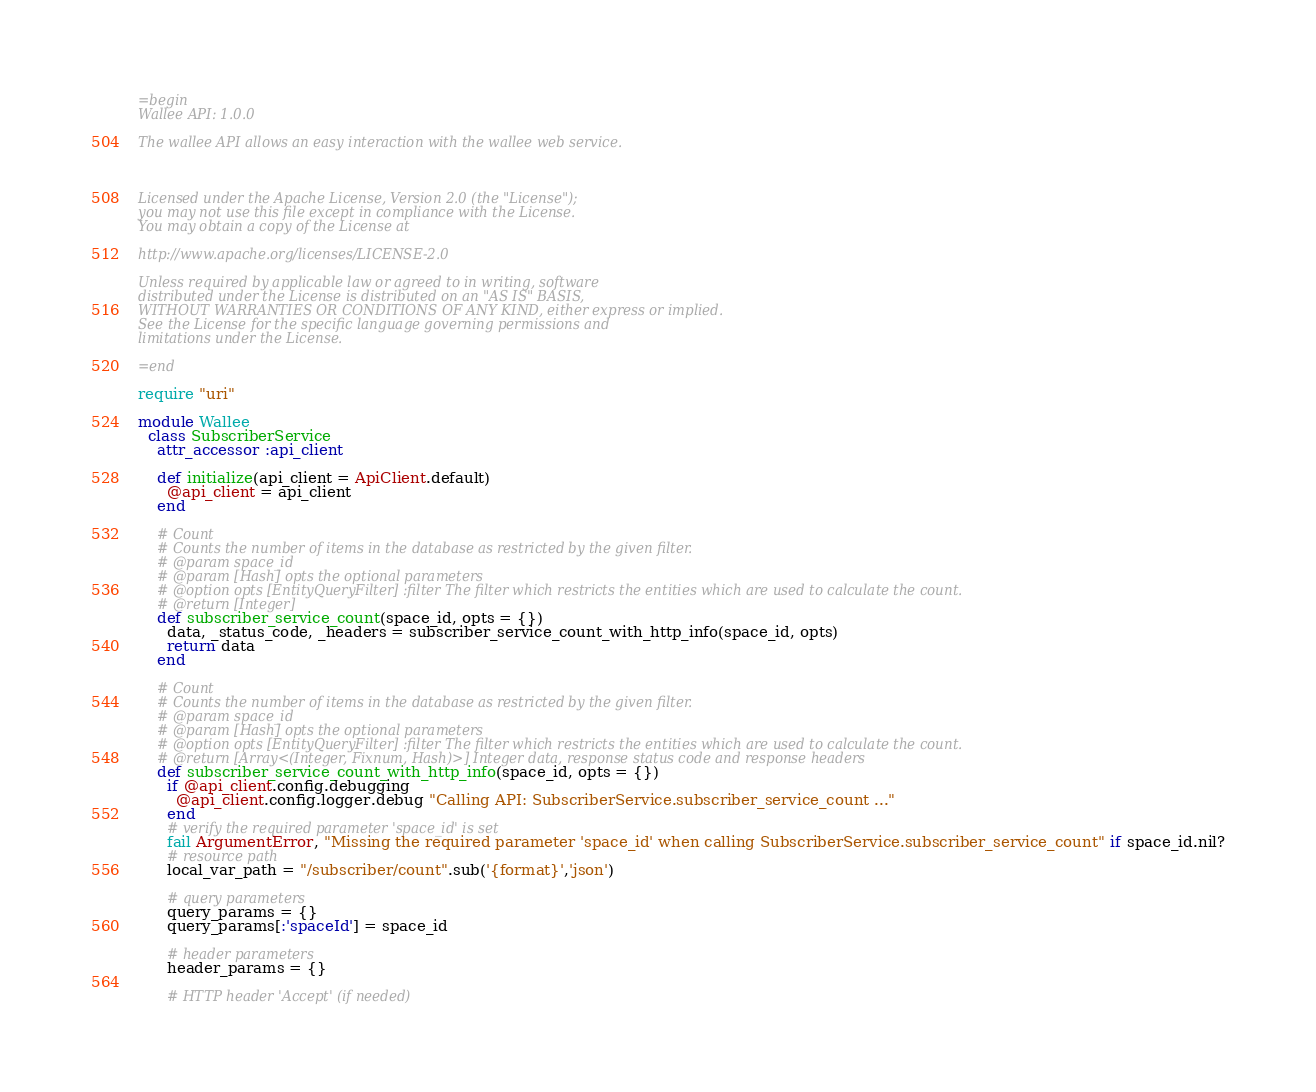<code> <loc_0><loc_0><loc_500><loc_500><_Ruby_>=begin
Wallee API: 1.0.0

The wallee API allows an easy interaction with the wallee web service.



Licensed under the Apache License, Version 2.0 (the "License");
you may not use this file except in compliance with the License.
You may obtain a copy of the License at

http://www.apache.org/licenses/LICENSE-2.0

Unless required by applicable law or agreed to in writing, software
distributed under the License is distributed on an "AS IS" BASIS,
WITHOUT WARRANTIES OR CONDITIONS OF ANY KIND, either express or implied.
See the License for the specific language governing permissions and
limitations under the License.

=end

require "uri"

module Wallee
  class SubscriberService
    attr_accessor :api_client

    def initialize(api_client = ApiClient.default)
      @api_client = api_client
    end

    # Count
    # Counts the number of items in the database as restricted by the given filter.
    # @param space_id 
    # @param [Hash] opts the optional parameters
    # @option opts [EntityQueryFilter] :filter The filter which restricts the entities which are used to calculate the count.
    # @return [Integer]
    def subscriber_service_count(space_id, opts = {})
      data, _status_code, _headers = subscriber_service_count_with_http_info(space_id, opts)
      return data
    end

    # Count
    # Counts the number of items in the database as restricted by the given filter.
    # @param space_id 
    # @param [Hash] opts the optional parameters
    # @option opts [EntityQueryFilter] :filter The filter which restricts the entities which are used to calculate the count.
    # @return [Array<(Integer, Fixnum, Hash)>] Integer data, response status code and response headers
    def subscriber_service_count_with_http_info(space_id, opts = {})
      if @api_client.config.debugging
        @api_client.config.logger.debug "Calling API: SubscriberService.subscriber_service_count ..."
      end
      # verify the required parameter 'space_id' is set
      fail ArgumentError, "Missing the required parameter 'space_id' when calling SubscriberService.subscriber_service_count" if space_id.nil?
      # resource path
      local_var_path = "/subscriber/count".sub('{format}','json')

      # query parameters
      query_params = {}
      query_params[:'spaceId'] = space_id

      # header parameters
      header_params = {}

      # HTTP header 'Accept' (if needed)</code> 